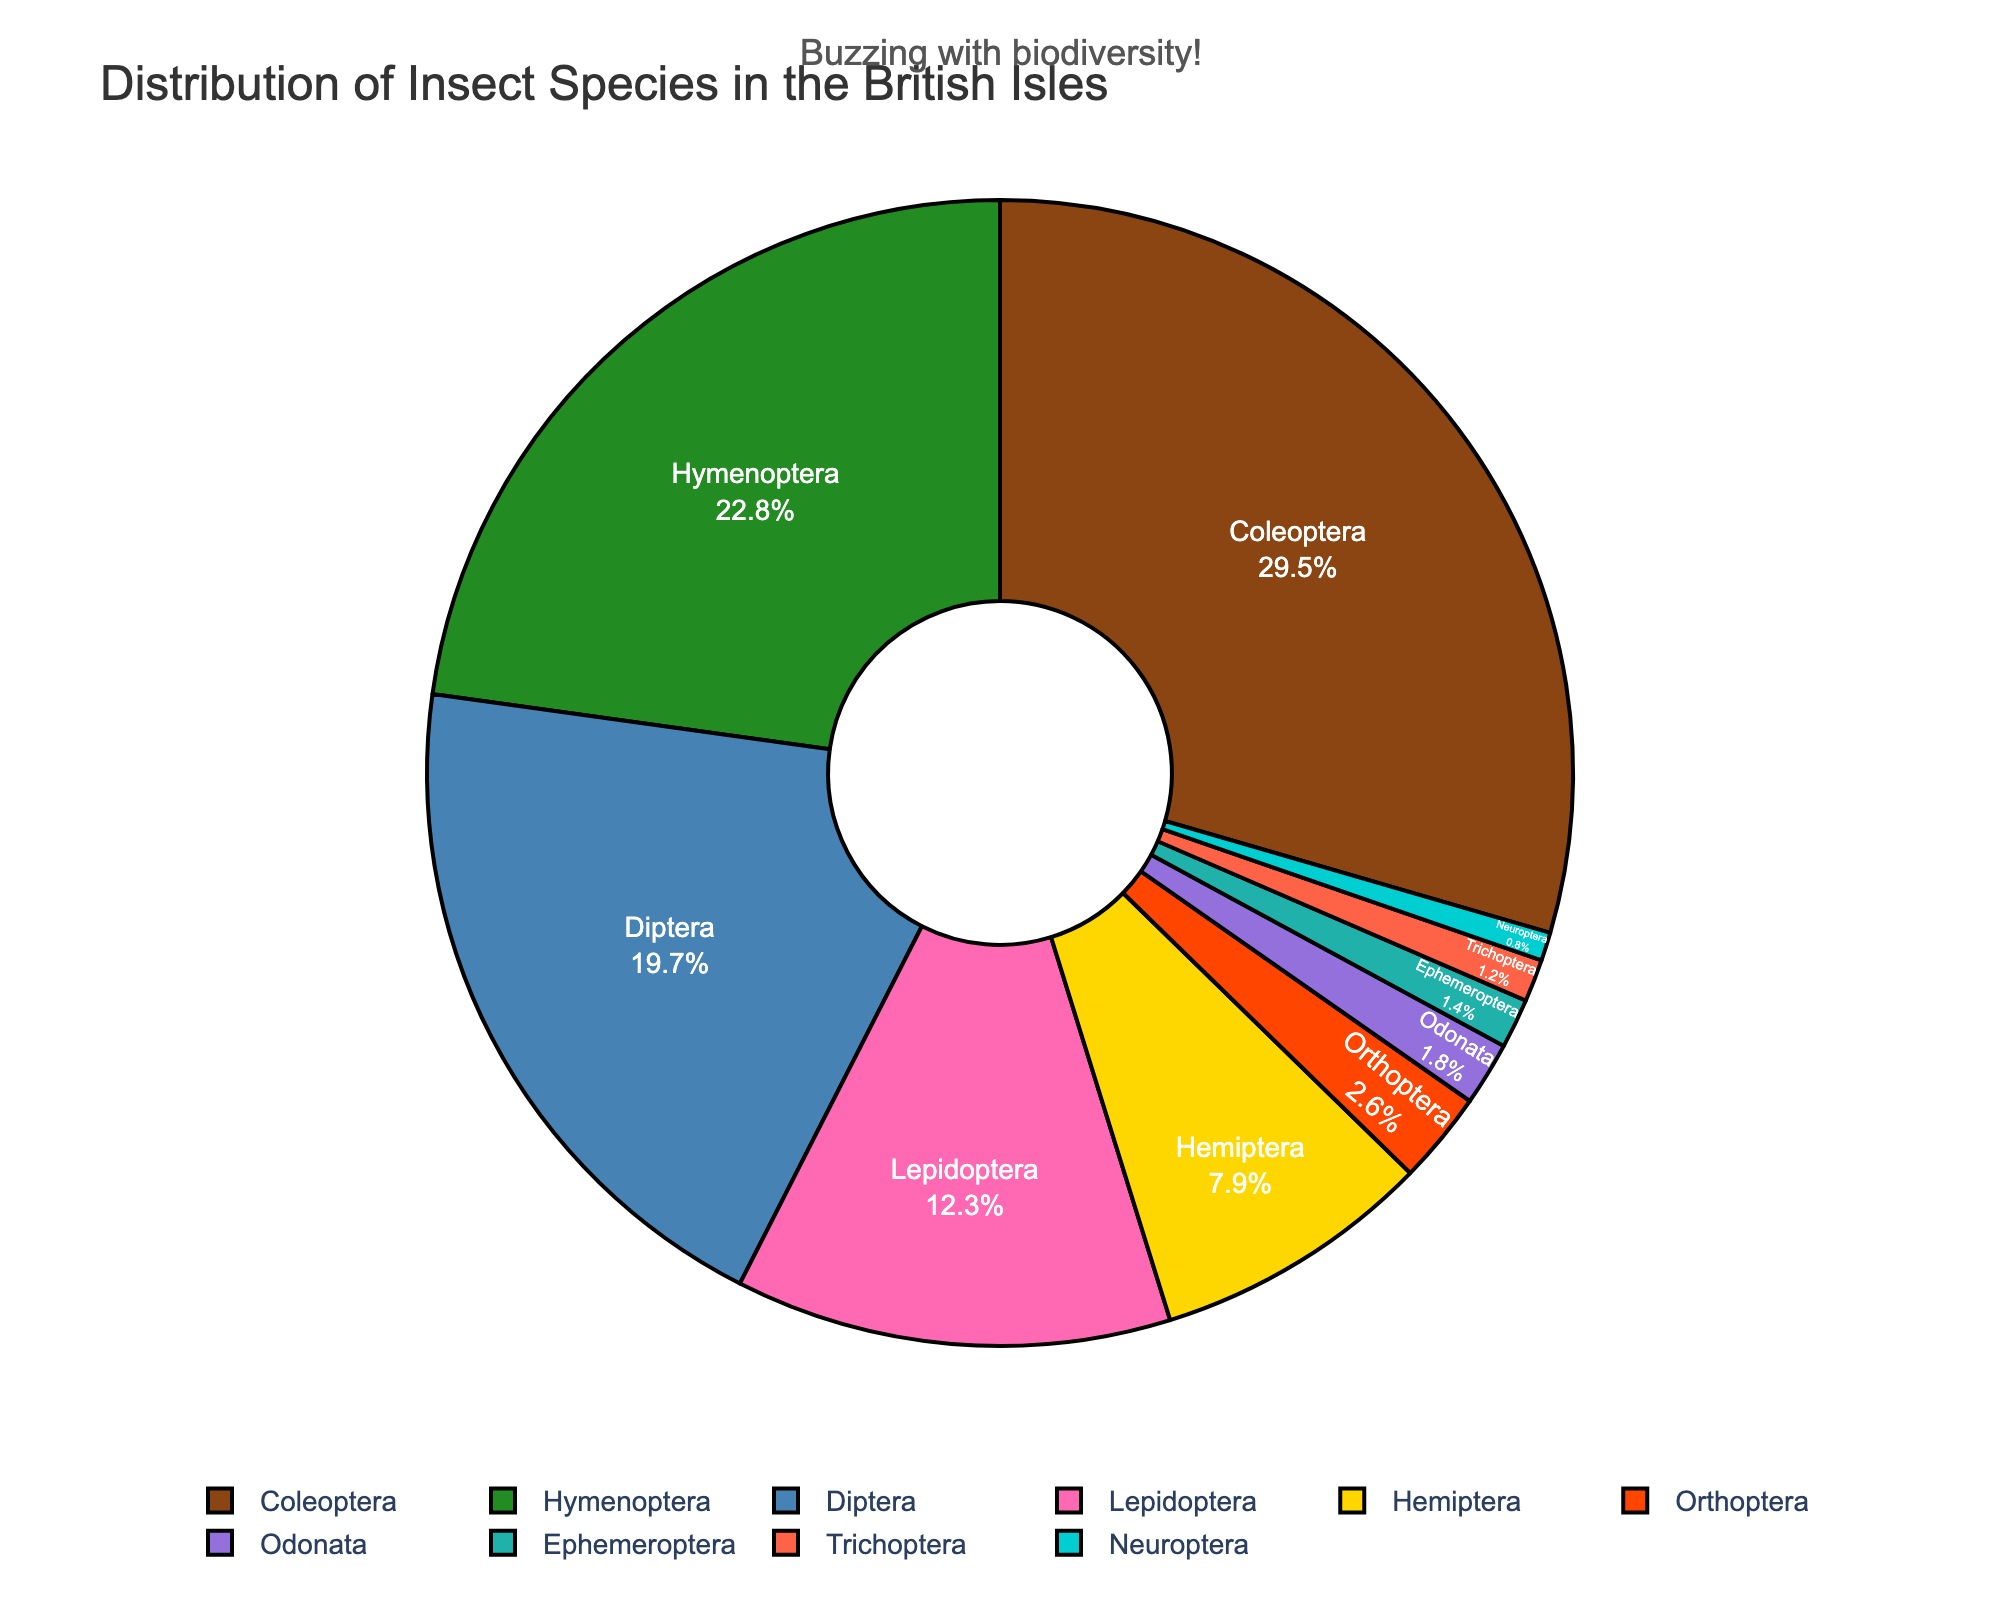Which insect order has the highest percentage in the British Isles? By examining the pie chart, we look for the order with the largest segment. The segment labeled "Coleoptera" is the largest, with 29.5%.
Answer: Coleoptera Which two insect orders together constitute more than 50% of the distribution? Looking at the percentages, Coleoptera (29.5%) and Hymenoptera (22.8%) are the largest groups. Adding these gives 29.5% + 22.8% = 52.3%, which is more than 50%.
Answer: Coleoptera and Hymenoptera What is the combined percentage of Lepidoptera and Diptera? Identifying the labels and percentages for Lepidoptera (12.3%) and Diptera (19.7%), we sum these values: 12.3% + 19.7% = 32%.
Answer: 32% Which order has a larger percentage, Hemiptera or Odonata, and by how much? Hemiptera is 7.9% and Odonata is 1.8%. The difference is 7.9% - 1.8% = 6.1%. Hemiptera is larger.
Answer: Hemiptera by 6.1% How does the percentage of Orthoptera compare to Odonata? Orthoptera is 2.6% and Odonata is 1.8%. Since 2.6% > 1.8%, Orthoptera is larger.
Answer: Orthoptera is larger Which segment is displayed in pink in the pie chart? The pie chart's visual attributes show the Hymenoptera segment in pink.
Answer: Hymenoptera By how much does the percentage of Coleoptera exceed that of Diptera? Coleoptera is 29.5% and Diptera is 19.7%. The difference is 29.5% - 19.7% = 9.8%.
Answer: 9.8% What is the average percentage of Orthoptera, Odonata, and Trichoptera? Their percentages are Orthoptera 2.6%, Odonata 1.8%, and Trichoptera 1.2%. Average: (2.6 + 1.8 + 1.2) / 3 = 1.87%.
Answer: 1.87% Which segments are smaller than 2%? Segments under 2% are identified as Odonata (1.8%), Ephemeroptera (1.4%), Trichoptera (1.2%), and Neuroptera (0.8%).
Answer: Odonata, Ephemeroptera, Trichoptera, and Neuroptera 